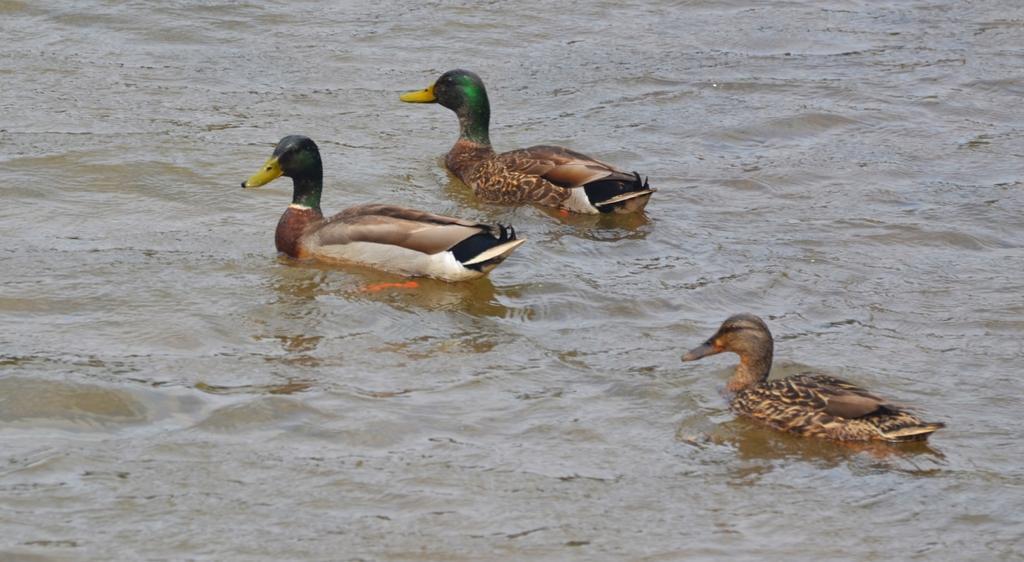How would you summarize this image in a sentence or two? In the center of the image we can see ducks on the water. 